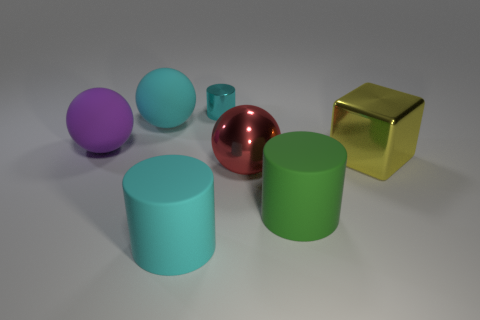Add 1 tiny gray objects. How many objects exist? 8 Subtract all balls. How many objects are left? 4 Subtract all red shiny balls. Subtract all large objects. How many objects are left? 0 Add 3 shiny balls. How many shiny balls are left? 4 Add 7 big cylinders. How many big cylinders exist? 9 Subtract 0 yellow cylinders. How many objects are left? 7 